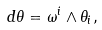<formula> <loc_0><loc_0><loc_500><loc_500>d \theta = \omega ^ { i } \wedge \theta _ { i } ,</formula> 